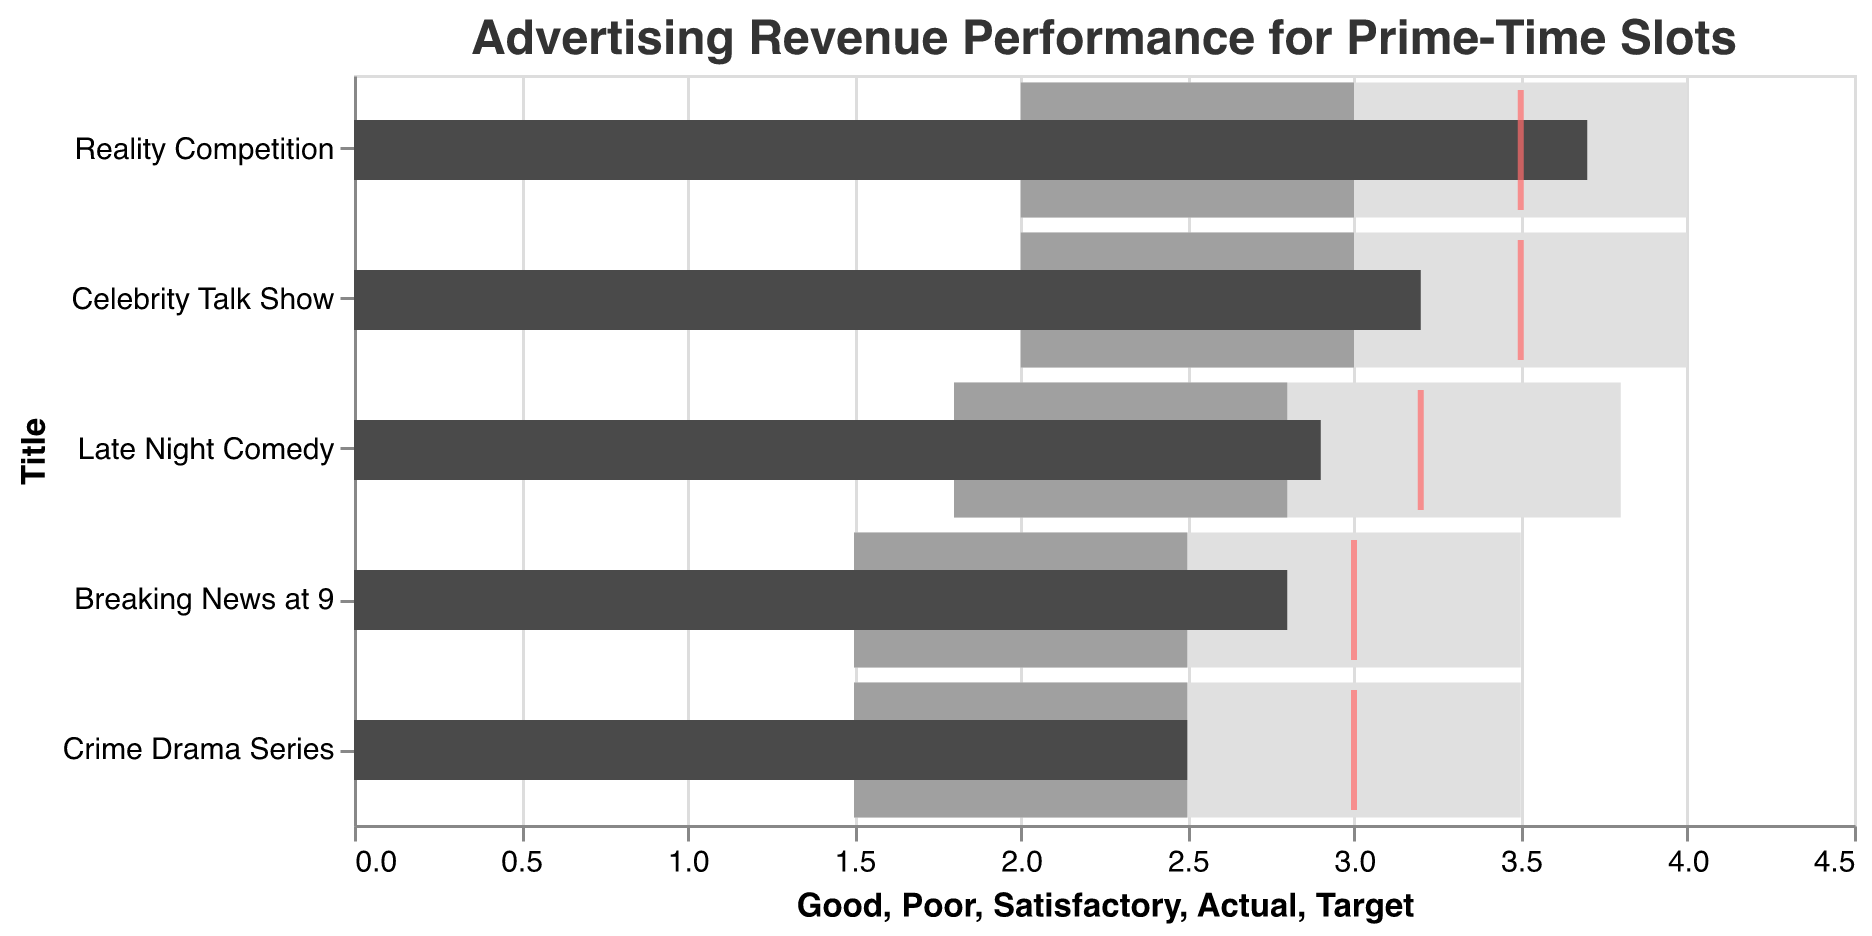What's the title of the chart? The title of the chart is found at the top of the figure. The chart is titled "Advertising Revenue Performance for Prime-Time Slots."
Answer: Advertising Revenue Performance for Prime-Time Slots Which TV show has the highest actual advertising revenue? From the figure, the bars indicating actual advertising revenue show the longest bar, which corresponds to the show "Reality Competition."
Answer: Reality Competition What color represents the actual advertising revenue in the chart? The color that represents the actual revenue bars in the chart is a darker shade (almost black).
Answer: Dark gray How many TV shows exceeded their target revenue? By looking at the bars and the red ticks, we can see which actual revenue bars (dark gray) surpass their respective target ticks. "Reality Competition" is the only one that exceeds its target.
Answer: 1 Which TV show has the closest actual revenue to its target? By observing the dark gray bars and the red ticks, "Celebrity Talk Show" has its actual revenue (3.2) closest to its target (3.5).
Answer: Celebrity Talk Show For "Breaking News at 9," is the actual revenue greater than the satisfactory threshold? The satisfactory range for "Breaking News at 9" goes from 2.5 to 3.5. The actual revenue is 2.8, which is within the satisfactory range.
Answer: Yes What is the combined actual advertising revenue for "Breaking News at 9" and "Crime Drama Series"? Adding the actual revenues, Breaking News at 9 (2.8) and Crime Drama Series (2.5), the combined value is 2.8 + 2.5 = 5.3.
Answer: 5.3 Which show underperformed compared to its target, but still hit the satisfactory mark? By comparing the actual revenues and targets, if an actual revenue is less than the target but within the satisfactory range, "Breaking News at 9" (2.8 < 3.0 and within 2.5 and 3.5) and "Late Night Comedy" (2.9 < 3.2 and within 2.8 and 3.8) fit this criteria.
Answer: Breaking News at 9, Late Night Comedy 